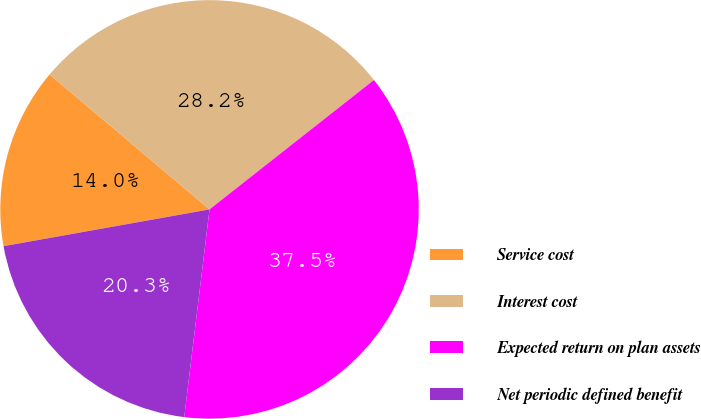Convert chart to OTSL. <chart><loc_0><loc_0><loc_500><loc_500><pie_chart><fcel>Service cost<fcel>Interest cost<fcel>Expected return on plan assets<fcel>Net periodic defined benefit<nl><fcel>13.97%<fcel>28.23%<fcel>37.54%<fcel>20.26%<nl></chart> 